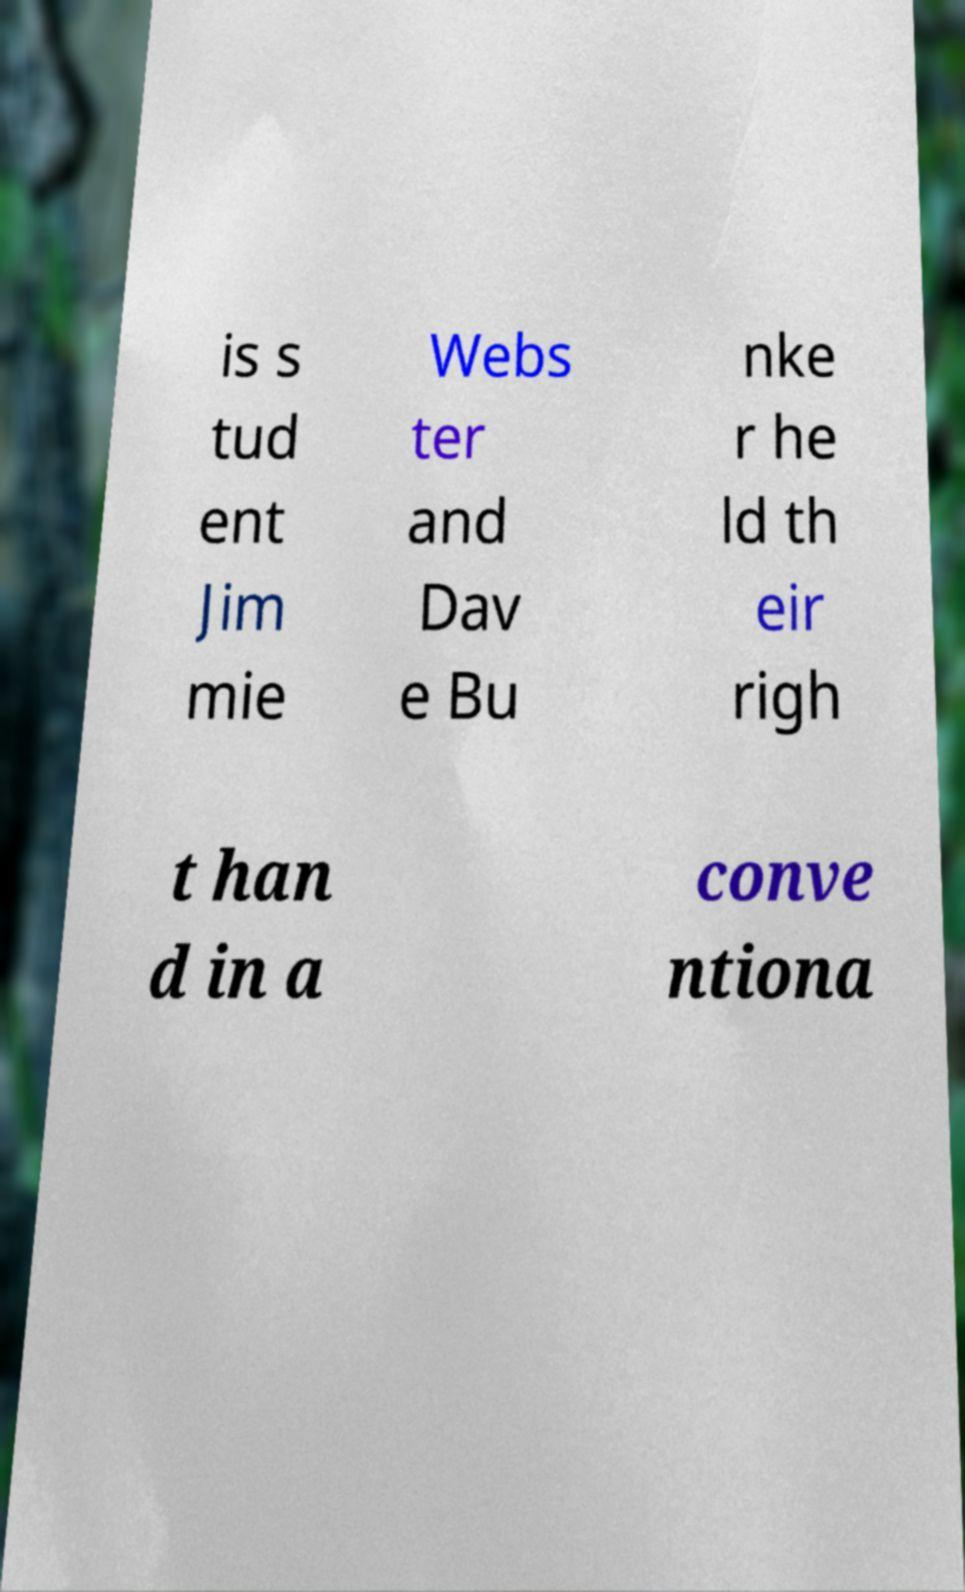Could you extract and type out the text from this image? is s tud ent Jim mie Webs ter and Dav e Bu nke r he ld th eir righ t han d in a conve ntiona 